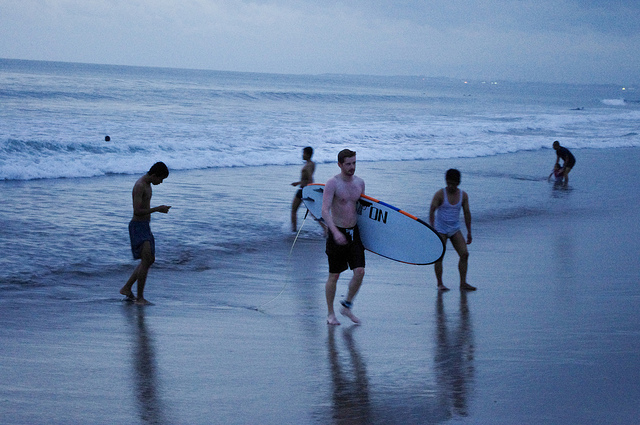Extract all visible text content from this image. ON 